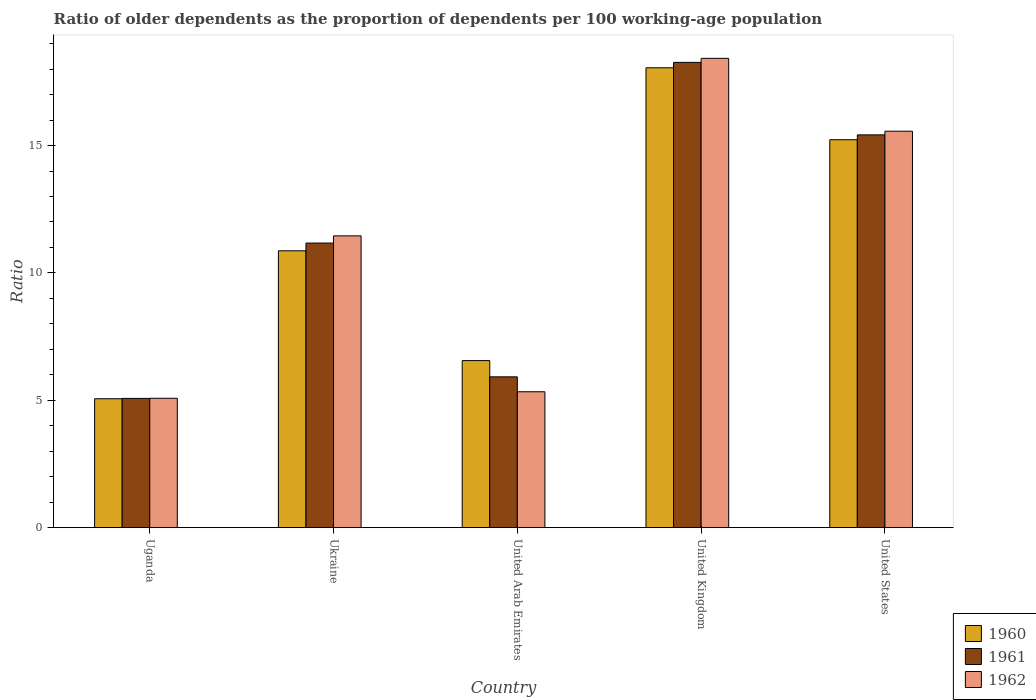How many groups of bars are there?
Ensure brevity in your answer.  5. Are the number of bars per tick equal to the number of legend labels?
Make the answer very short. Yes. Are the number of bars on each tick of the X-axis equal?
Keep it short and to the point. Yes. In how many cases, is the number of bars for a given country not equal to the number of legend labels?
Make the answer very short. 0. What is the age dependency ratio(old) in 1960 in United States?
Ensure brevity in your answer.  15.23. Across all countries, what is the maximum age dependency ratio(old) in 1962?
Give a very brief answer. 18.43. Across all countries, what is the minimum age dependency ratio(old) in 1961?
Your answer should be compact. 5.07. In which country was the age dependency ratio(old) in 1961 minimum?
Ensure brevity in your answer.  Uganda. What is the total age dependency ratio(old) in 1960 in the graph?
Offer a very short reply. 55.77. What is the difference between the age dependency ratio(old) in 1961 in Uganda and that in United Arab Emirates?
Offer a terse response. -0.85. What is the difference between the age dependency ratio(old) in 1960 in Ukraine and the age dependency ratio(old) in 1961 in United States?
Offer a very short reply. -4.55. What is the average age dependency ratio(old) in 1961 per country?
Your answer should be compact. 11.17. What is the difference between the age dependency ratio(old) of/in 1962 and age dependency ratio(old) of/in 1961 in Uganda?
Provide a succinct answer. 0.01. In how many countries, is the age dependency ratio(old) in 1962 greater than 7?
Provide a succinct answer. 3. What is the ratio of the age dependency ratio(old) in 1961 in United Kingdom to that in United States?
Give a very brief answer. 1.18. Is the difference between the age dependency ratio(old) in 1962 in Ukraine and United Kingdom greater than the difference between the age dependency ratio(old) in 1961 in Ukraine and United Kingdom?
Offer a terse response. Yes. What is the difference between the highest and the second highest age dependency ratio(old) in 1962?
Provide a short and direct response. 6.97. What is the difference between the highest and the lowest age dependency ratio(old) in 1961?
Your answer should be very brief. 13.19. In how many countries, is the age dependency ratio(old) in 1960 greater than the average age dependency ratio(old) in 1960 taken over all countries?
Your answer should be very brief. 2. Is the sum of the age dependency ratio(old) in 1962 in United Arab Emirates and United Kingdom greater than the maximum age dependency ratio(old) in 1961 across all countries?
Your response must be concise. Yes. What does the 2nd bar from the right in Uganda represents?
Make the answer very short. 1961. Is it the case that in every country, the sum of the age dependency ratio(old) in 1961 and age dependency ratio(old) in 1962 is greater than the age dependency ratio(old) in 1960?
Give a very brief answer. Yes. How many bars are there?
Give a very brief answer. 15. How many countries are there in the graph?
Offer a very short reply. 5. Where does the legend appear in the graph?
Make the answer very short. Bottom right. How many legend labels are there?
Offer a very short reply. 3. What is the title of the graph?
Your answer should be very brief. Ratio of older dependents as the proportion of dependents per 100 working-age population. Does "2011" appear as one of the legend labels in the graph?
Make the answer very short. No. What is the label or title of the X-axis?
Provide a short and direct response. Country. What is the label or title of the Y-axis?
Offer a terse response. Ratio. What is the Ratio in 1960 in Uganda?
Your answer should be very brief. 5.06. What is the Ratio of 1961 in Uganda?
Offer a terse response. 5.07. What is the Ratio in 1962 in Uganda?
Ensure brevity in your answer.  5.08. What is the Ratio of 1960 in Ukraine?
Make the answer very short. 10.87. What is the Ratio in 1961 in Ukraine?
Make the answer very short. 11.17. What is the Ratio in 1962 in Ukraine?
Your answer should be very brief. 11.46. What is the Ratio of 1960 in United Arab Emirates?
Offer a terse response. 6.56. What is the Ratio in 1961 in United Arab Emirates?
Give a very brief answer. 5.92. What is the Ratio of 1962 in United Arab Emirates?
Provide a short and direct response. 5.33. What is the Ratio of 1960 in United Kingdom?
Offer a terse response. 18.05. What is the Ratio in 1961 in United Kingdom?
Offer a terse response. 18.27. What is the Ratio of 1962 in United Kingdom?
Provide a short and direct response. 18.43. What is the Ratio of 1960 in United States?
Make the answer very short. 15.23. What is the Ratio of 1961 in United States?
Offer a very short reply. 15.42. What is the Ratio in 1962 in United States?
Keep it short and to the point. 15.56. Across all countries, what is the maximum Ratio in 1960?
Offer a very short reply. 18.05. Across all countries, what is the maximum Ratio of 1961?
Offer a terse response. 18.27. Across all countries, what is the maximum Ratio in 1962?
Offer a very short reply. 18.43. Across all countries, what is the minimum Ratio of 1960?
Ensure brevity in your answer.  5.06. Across all countries, what is the minimum Ratio in 1961?
Provide a succinct answer. 5.07. Across all countries, what is the minimum Ratio of 1962?
Offer a terse response. 5.08. What is the total Ratio of 1960 in the graph?
Make the answer very short. 55.77. What is the total Ratio of 1961 in the graph?
Provide a succinct answer. 55.86. What is the total Ratio in 1962 in the graph?
Provide a short and direct response. 55.86. What is the difference between the Ratio in 1960 in Uganda and that in Ukraine?
Ensure brevity in your answer.  -5.81. What is the difference between the Ratio of 1961 in Uganda and that in Ukraine?
Keep it short and to the point. -6.1. What is the difference between the Ratio of 1962 in Uganda and that in Ukraine?
Give a very brief answer. -6.38. What is the difference between the Ratio in 1960 in Uganda and that in United Arab Emirates?
Your answer should be compact. -1.5. What is the difference between the Ratio of 1961 in Uganda and that in United Arab Emirates?
Provide a succinct answer. -0.85. What is the difference between the Ratio in 1962 in Uganda and that in United Arab Emirates?
Make the answer very short. -0.25. What is the difference between the Ratio in 1960 in Uganda and that in United Kingdom?
Provide a succinct answer. -12.99. What is the difference between the Ratio of 1961 in Uganda and that in United Kingdom?
Your answer should be compact. -13.19. What is the difference between the Ratio of 1962 in Uganda and that in United Kingdom?
Keep it short and to the point. -13.35. What is the difference between the Ratio in 1960 in Uganda and that in United States?
Give a very brief answer. -10.17. What is the difference between the Ratio of 1961 in Uganda and that in United States?
Offer a very short reply. -10.35. What is the difference between the Ratio of 1962 in Uganda and that in United States?
Make the answer very short. -10.48. What is the difference between the Ratio in 1960 in Ukraine and that in United Arab Emirates?
Your answer should be compact. 4.31. What is the difference between the Ratio of 1961 in Ukraine and that in United Arab Emirates?
Give a very brief answer. 5.25. What is the difference between the Ratio of 1962 in Ukraine and that in United Arab Emirates?
Your answer should be very brief. 6.12. What is the difference between the Ratio in 1960 in Ukraine and that in United Kingdom?
Your answer should be very brief. -7.18. What is the difference between the Ratio of 1961 in Ukraine and that in United Kingdom?
Provide a succinct answer. -7.09. What is the difference between the Ratio of 1962 in Ukraine and that in United Kingdom?
Offer a very short reply. -6.97. What is the difference between the Ratio of 1960 in Ukraine and that in United States?
Make the answer very short. -4.36. What is the difference between the Ratio in 1961 in Ukraine and that in United States?
Provide a succinct answer. -4.25. What is the difference between the Ratio in 1962 in Ukraine and that in United States?
Offer a terse response. -4.11. What is the difference between the Ratio of 1960 in United Arab Emirates and that in United Kingdom?
Offer a very short reply. -11.5. What is the difference between the Ratio in 1961 in United Arab Emirates and that in United Kingdom?
Your response must be concise. -12.35. What is the difference between the Ratio of 1962 in United Arab Emirates and that in United Kingdom?
Provide a succinct answer. -13.09. What is the difference between the Ratio in 1960 in United Arab Emirates and that in United States?
Your answer should be compact. -8.67. What is the difference between the Ratio of 1961 in United Arab Emirates and that in United States?
Offer a terse response. -9.5. What is the difference between the Ratio of 1962 in United Arab Emirates and that in United States?
Your answer should be very brief. -10.23. What is the difference between the Ratio in 1960 in United Kingdom and that in United States?
Your answer should be compact. 2.82. What is the difference between the Ratio in 1961 in United Kingdom and that in United States?
Offer a very short reply. 2.85. What is the difference between the Ratio of 1962 in United Kingdom and that in United States?
Provide a succinct answer. 2.86. What is the difference between the Ratio in 1960 in Uganda and the Ratio in 1961 in Ukraine?
Keep it short and to the point. -6.11. What is the difference between the Ratio of 1960 in Uganda and the Ratio of 1962 in Ukraine?
Provide a short and direct response. -6.39. What is the difference between the Ratio of 1961 in Uganda and the Ratio of 1962 in Ukraine?
Offer a terse response. -6.38. What is the difference between the Ratio of 1960 in Uganda and the Ratio of 1961 in United Arab Emirates?
Your answer should be very brief. -0.86. What is the difference between the Ratio of 1960 in Uganda and the Ratio of 1962 in United Arab Emirates?
Make the answer very short. -0.27. What is the difference between the Ratio of 1961 in Uganda and the Ratio of 1962 in United Arab Emirates?
Your answer should be very brief. -0.26. What is the difference between the Ratio in 1960 in Uganda and the Ratio in 1961 in United Kingdom?
Keep it short and to the point. -13.21. What is the difference between the Ratio of 1960 in Uganda and the Ratio of 1962 in United Kingdom?
Give a very brief answer. -13.36. What is the difference between the Ratio of 1961 in Uganda and the Ratio of 1962 in United Kingdom?
Your response must be concise. -13.35. What is the difference between the Ratio of 1960 in Uganda and the Ratio of 1961 in United States?
Provide a short and direct response. -10.36. What is the difference between the Ratio in 1960 in Uganda and the Ratio in 1962 in United States?
Make the answer very short. -10.5. What is the difference between the Ratio in 1961 in Uganda and the Ratio in 1962 in United States?
Offer a very short reply. -10.49. What is the difference between the Ratio of 1960 in Ukraine and the Ratio of 1961 in United Arab Emirates?
Provide a succinct answer. 4.95. What is the difference between the Ratio in 1960 in Ukraine and the Ratio in 1962 in United Arab Emirates?
Give a very brief answer. 5.54. What is the difference between the Ratio in 1961 in Ukraine and the Ratio in 1962 in United Arab Emirates?
Make the answer very short. 5.84. What is the difference between the Ratio in 1960 in Ukraine and the Ratio in 1961 in United Kingdom?
Keep it short and to the point. -7.4. What is the difference between the Ratio in 1960 in Ukraine and the Ratio in 1962 in United Kingdom?
Provide a short and direct response. -7.56. What is the difference between the Ratio in 1961 in Ukraine and the Ratio in 1962 in United Kingdom?
Give a very brief answer. -7.25. What is the difference between the Ratio in 1960 in Ukraine and the Ratio in 1961 in United States?
Offer a terse response. -4.55. What is the difference between the Ratio in 1960 in Ukraine and the Ratio in 1962 in United States?
Provide a succinct answer. -4.69. What is the difference between the Ratio of 1961 in Ukraine and the Ratio of 1962 in United States?
Give a very brief answer. -4.39. What is the difference between the Ratio in 1960 in United Arab Emirates and the Ratio in 1961 in United Kingdom?
Keep it short and to the point. -11.71. What is the difference between the Ratio in 1960 in United Arab Emirates and the Ratio in 1962 in United Kingdom?
Ensure brevity in your answer.  -11.87. What is the difference between the Ratio of 1961 in United Arab Emirates and the Ratio of 1962 in United Kingdom?
Provide a short and direct response. -12.5. What is the difference between the Ratio in 1960 in United Arab Emirates and the Ratio in 1961 in United States?
Ensure brevity in your answer.  -8.86. What is the difference between the Ratio in 1960 in United Arab Emirates and the Ratio in 1962 in United States?
Your answer should be very brief. -9.01. What is the difference between the Ratio in 1961 in United Arab Emirates and the Ratio in 1962 in United States?
Give a very brief answer. -9.64. What is the difference between the Ratio of 1960 in United Kingdom and the Ratio of 1961 in United States?
Provide a succinct answer. 2.63. What is the difference between the Ratio of 1960 in United Kingdom and the Ratio of 1962 in United States?
Give a very brief answer. 2.49. What is the difference between the Ratio in 1961 in United Kingdom and the Ratio in 1962 in United States?
Your response must be concise. 2.7. What is the average Ratio of 1960 per country?
Keep it short and to the point. 11.15. What is the average Ratio of 1961 per country?
Your answer should be compact. 11.17. What is the average Ratio in 1962 per country?
Make the answer very short. 11.17. What is the difference between the Ratio in 1960 and Ratio in 1961 in Uganda?
Your answer should be compact. -0.01. What is the difference between the Ratio in 1960 and Ratio in 1962 in Uganda?
Ensure brevity in your answer.  -0.02. What is the difference between the Ratio of 1961 and Ratio of 1962 in Uganda?
Provide a short and direct response. -0.01. What is the difference between the Ratio of 1960 and Ratio of 1961 in Ukraine?
Your answer should be compact. -0.3. What is the difference between the Ratio in 1960 and Ratio in 1962 in Ukraine?
Provide a short and direct response. -0.59. What is the difference between the Ratio in 1961 and Ratio in 1962 in Ukraine?
Offer a very short reply. -0.28. What is the difference between the Ratio in 1960 and Ratio in 1961 in United Arab Emirates?
Offer a terse response. 0.64. What is the difference between the Ratio in 1960 and Ratio in 1962 in United Arab Emirates?
Ensure brevity in your answer.  1.22. What is the difference between the Ratio in 1961 and Ratio in 1962 in United Arab Emirates?
Your answer should be compact. 0.59. What is the difference between the Ratio in 1960 and Ratio in 1961 in United Kingdom?
Your response must be concise. -0.21. What is the difference between the Ratio of 1960 and Ratio of 1962 in United Kingdom?
Give a very brief answer. -0.37. What is the difference between the Ratio of 1961 and Ratio of 1962 in United Kingdom?
Your answer should be very brief. -0.16. What is the difference between the Ratio in 1960 and Ratio in 1961 in United States?
Provide a short and direct response. -0.19. What is the difference between the Ratio of 1960 and Ratio of 1962 in United States?
Make the answer very short. -0.33. What is the difference between the Ratio of 1961 and Ratio of 1962 in United States?
Offer a terse response. -0.14. What is the ratio of the Ratio of 1960 in Uganda to that in Ukraine?
Keep it short and to the point. 0.47. What is the ratio of the Ratio of 1961 in Uganda to that in Ukraine?
Ensure brevity in your answer.  0.45. What is the ratio of the Ratio of 1962 in Uganda to that in Ukraine?
Give a very brief answer. 0.44. What is the ratio of the Ratio in 1960 in Uganda to that in United Arab Emirates?
Give a very brief answer. 0.77. What is the ratio of the Ratio of 1961 in Uganda to that in United Arab Emirates?
Your response must be concise. 0.86. What is the ratio of the Ratio in 1962 in Uganda to that in United Arab Emirates?
Your answer should be very brief. 0.95. What is the ratio of the Ratio in 1960 in Uganda to that in United Kingdom?
Make the answer very short. 0.28. What is the ratio of the Ratio of 1961 in Uganda to that in United Kingdom?
Ensure brevity in your answer.  0.28. What is the ratio of the Ratio in 1962 in Uganda to that in United Kingdom?
Provide a succinct answer. 0.28. What is the ratio of the Ratio in 1960 in Uganda to that in United States?
Ensure brevity in your answer.  0.33. What is the ratio of the Ratio of 1961 in Uganda to that in United States?
Offer a terse response. 0.33. What is the ratio of the Ratio of 1962 in Uganda to that in United States?
Your answer should be compact. 0.33. What is the ratio of the Ratio in 1960 in Ukraine to that in United Arab Emirates?
Provide a succinct answer. 1.66. What is the ratio of the Ratio in 1961 in Ukraine to that in United Arab Emirates?
Keep it short and to the point. 1.89. What is the ratio of the Ratio of 1962 in Ukraine to that in United Arab Emirates?
Provide a succinct answer. 2.15. What is the ratio of the Ratio in 1960 in Ukraine to that in United Kingdom?
Give a very brief answer. 0.6. What is the ratio of the Ratio in 1961 in Ukraine to that in United Kingdom?
Your answer should be compact. 0.61. What is the ratio of the Ratio of 1962 in Ukraine to that in United Kingdom?
Your answer should be compact. 0.62. What is the ratio of the Ratio in 1960 in Ukraine to that in United States?
Give a very brief answer. 0.71. What is the ratio of the Ratio of 1961 in Ukraine to that in United States?
Provide a succinct answer. 0.72. What is the ratio of the Ratio in 1962 in Ukraine to that in United States?
Provide a succinct answer. 0.74. What is the ratio of the Ratio in 1960 in United Arab Emirates to that in United Kingdom?
Give a very brief answer. 0.36. What is the ratio of the Ratio in 1961 in United Arab Emirates to that in United Kingdom?
Offer a terse response. 0.32. What is the ratio of the Ratio of 1962 in United Arab Emirates to that in United Kingdom?
Ensure brevity in your answer.  0.29. What is the ratio of the Ratio of 1960 in United Arab Emirates to that in United States?
Make the answer very short. 0.43. What is the ratio of the Ratio in 1961 in United Arab Emirates to that in United States?
Offer a very short reply. 0.38. What is the ratio of the Ratio of 1962 in United Arab Emirates to that in United States?
Give a very brief answer. 0.34. What is the ratio of the Ratio of 1960 in United Kingdom to that in United States?
Your answer should be very brief. 1.19. What is the ratio of the Ratio in 1961 in United Kingdom to that in United States?
Your answer should be very brief. 1.18. What is the ratio of the Ratio in 1962 in United Kingdom to that in United States?
Give a very brief answer. 1.18. What is the difference between the highest and the second highest Ratio of 1960?
Offer a terse response. 2.82. What is the difference between the highest and the second highest Ratio of 1961?
Give a very brief answer. 2.85. What is the difference between the highest and the second highest Ratio in 1962?
Your answer should be very brief. 2.86. What is the difference between the highest and the lowest Ratio of 1960?
Keep it short and to the point. 12.99. What is the difference between the highest and the lowest Ratio of 1961?
Make the answer very short. 13.19. What is the difference between the highest and the lowest Ratio of 1962?
Ensure brevity in your answer.  13.35. 